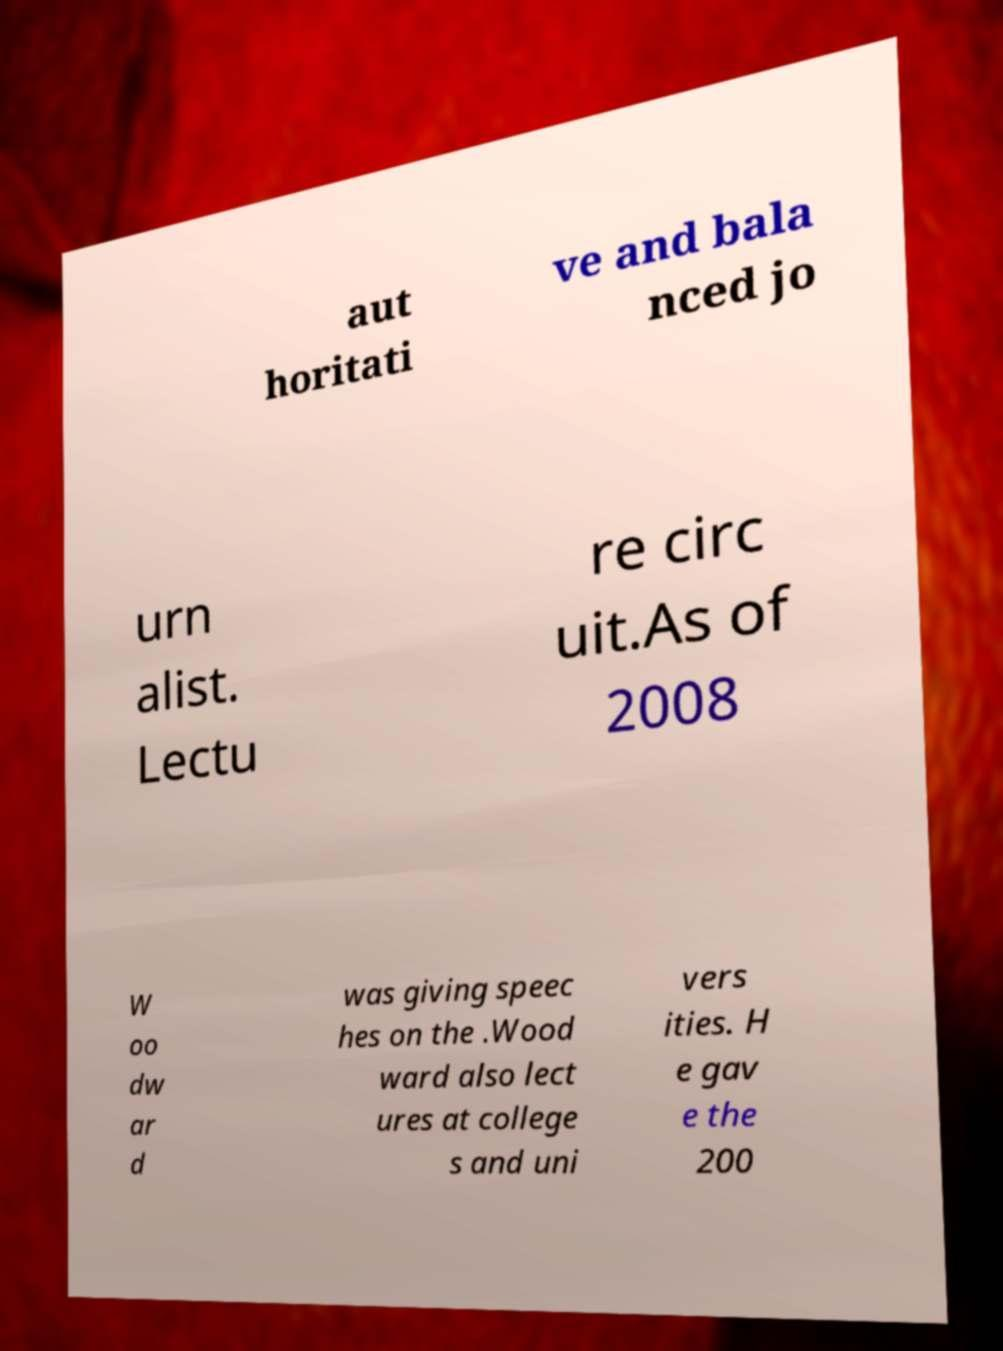Can you read and provide the text displayed in the image?This photo seems to have some interesting text. Can you extract and type it out for me? aut horitati ve and bala nced jo urn alist. Lectu re circ uit.As of 2008 W oo dw ar d was giving speec hes on the .Wood ward also lect ures at college s and uni vers ities. H e gav e the 200 